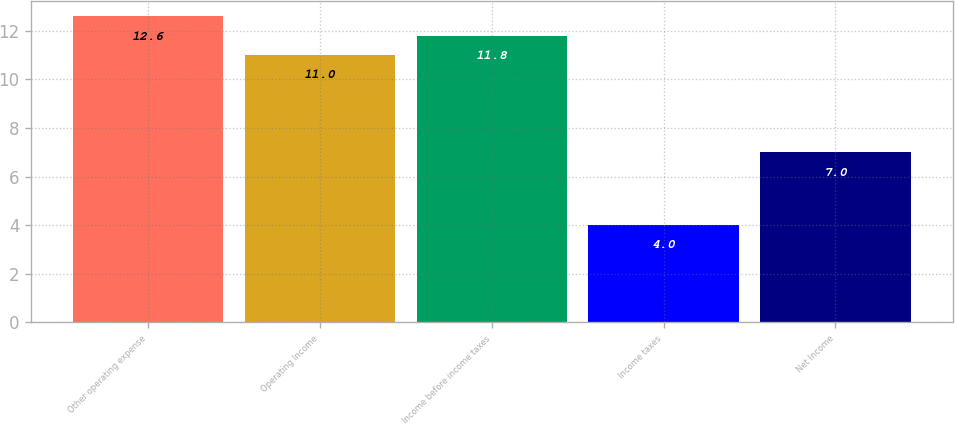Convert chart. <chart><loc_0><loc_0><loc_500><loc_500><bar_chart><fcel>Other operating expense<fcel>Operating Income<fcel>Income before income taxes<fcel>Income taxes<fcel>Net Income<nl><fcel>12.6<fcel>11<fcel>11.8<fcel>4<fcel>7<nl></chart> 